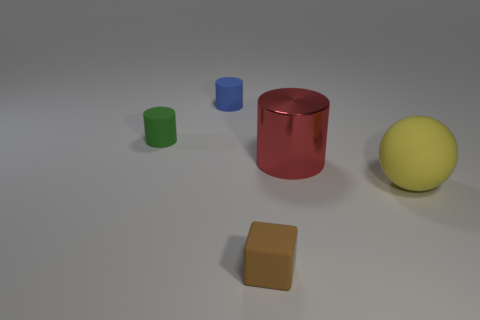Add 2 brown shiny balls. How many objects exist? 7 Subtract all cylinders. How many objects are left? 2 Subtract all red objects. Subtract all red metal cylinders. How many objects are left? 3 Add 5 big red metal things. How many big red metal things are left? 6 Add 1 tiny objects. How many tiny objects exist? 4 Subtract 1 green cylinders. How many objects are left? 4 